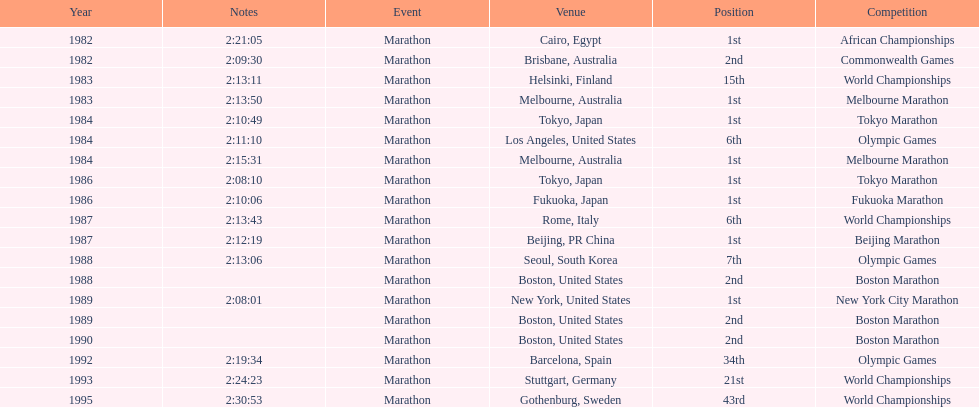Which was the only competition to occur in china? Beijing Marathon. 